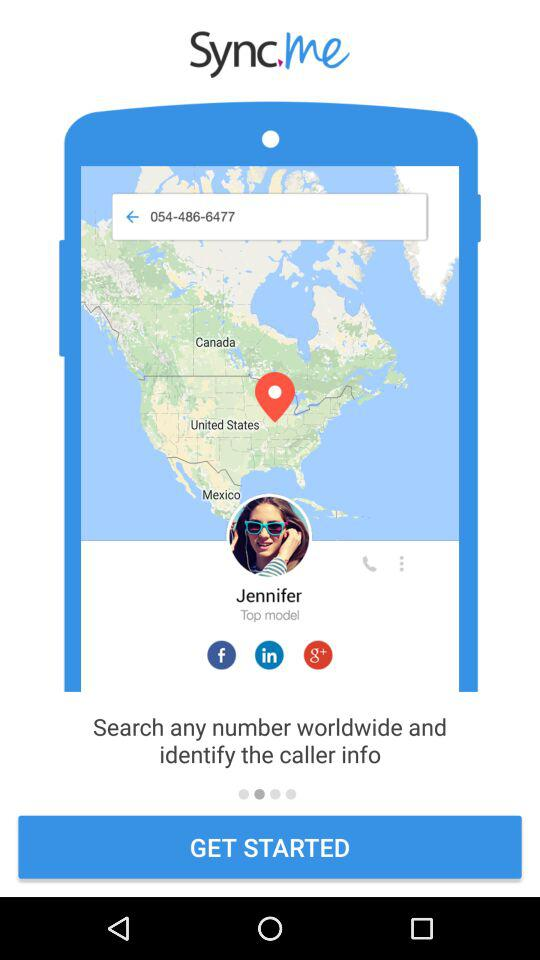What is the name of the user? The name of the user is "Jennifer". 